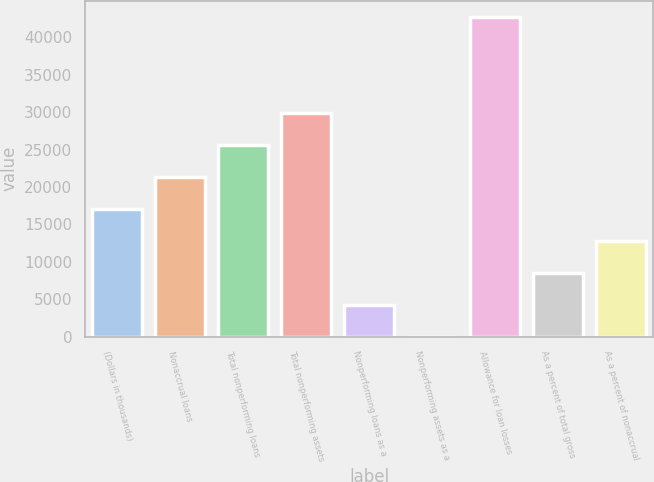Convert chart. <chart><loc_0><loc_0><loc_500><loc_500><bar_chart><fcel>(Dollars in thousands)<fcel>Nonaccrual loans<fcel>Total nonperforming loans<fcel>Total nonperforming assets<fcel>Nonperforming loans as a<fcel>Nonperforming assets as a<fcel>Allowance for loan losses<fcel>As a percent of total gross<fcel>As a percent of nonaccrual<nl><fcel>17099<fcel>21373.6<fcel>25648.3<fcel>29923<fcel>4274.94<fcel>0.27<fcel>42747<fcel>8549.61<fcel>12824.3<nl></chart> 